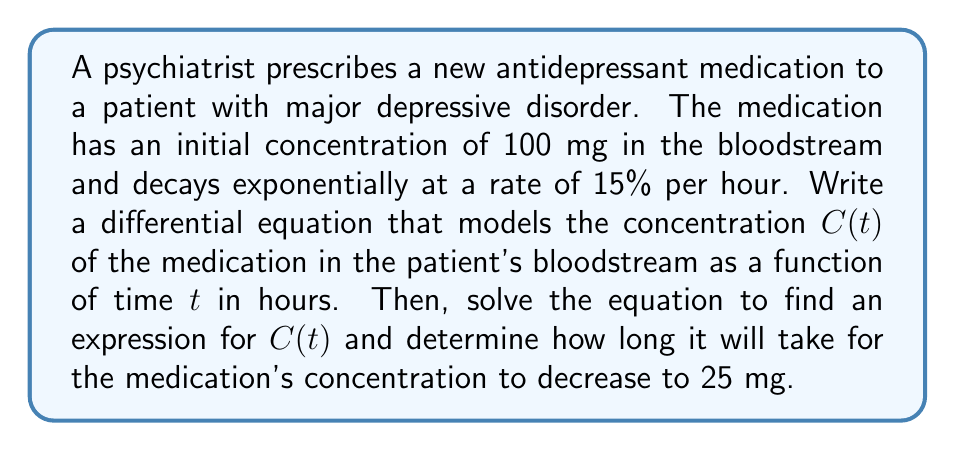Can you solve this math problem? 1) First, let's form the differential equation. The rate of change of the concentration is proportional to the current concentration:

   $$\frac{dC}{dt} = -kC$$

   where $k$ is the decay constant.

2) We're given that the decay rate is 15% per hour. This means:

   $$k = 0.15$$

3) So our differential equation is:

   $$\frac{dC}{dt} = -0.15C$$

4) To solve this, we can use separation of variables:

   $$\frac{dC}{C} = -0.15dt$$

5) Integrating both sides:

   $$\int \frac{dC}{C} = \int -0.15dt$$
   $$\ln|C| = -0.15t + K$$

6) Exponentiating both sides:

   $$C = e^{-0.15t + K} = Ae^{-0.15t}$$

   where $A = e^K$ is a constant.

7) We can find $A$ using the initial condition $C(0) = 100$:

   $$100 = Ae^{-0.15(0)} = A$$

8) Therefore, the solution is:

   $$C(t) = 100e^{-0.15t}$$

9) To find when the concentration reaches 25 mg, we solve:

   $$25 = 100e^{-0.15t}$$
   $$0.25 = e^{-0.15t}$$
   $$\ln(0.25) = -0.15t$$
   $$t = \frac{\ln(0.25)}{-0.15} \approx 9.2 hours$$
Answer: The differential equation is $\frac{dC}{dt} = -0.15C$. The solution is $C(t) = 100e^{-0.15t}$. It will take approximately 9.2 hours for the concentration to decrease to 25 mg. 